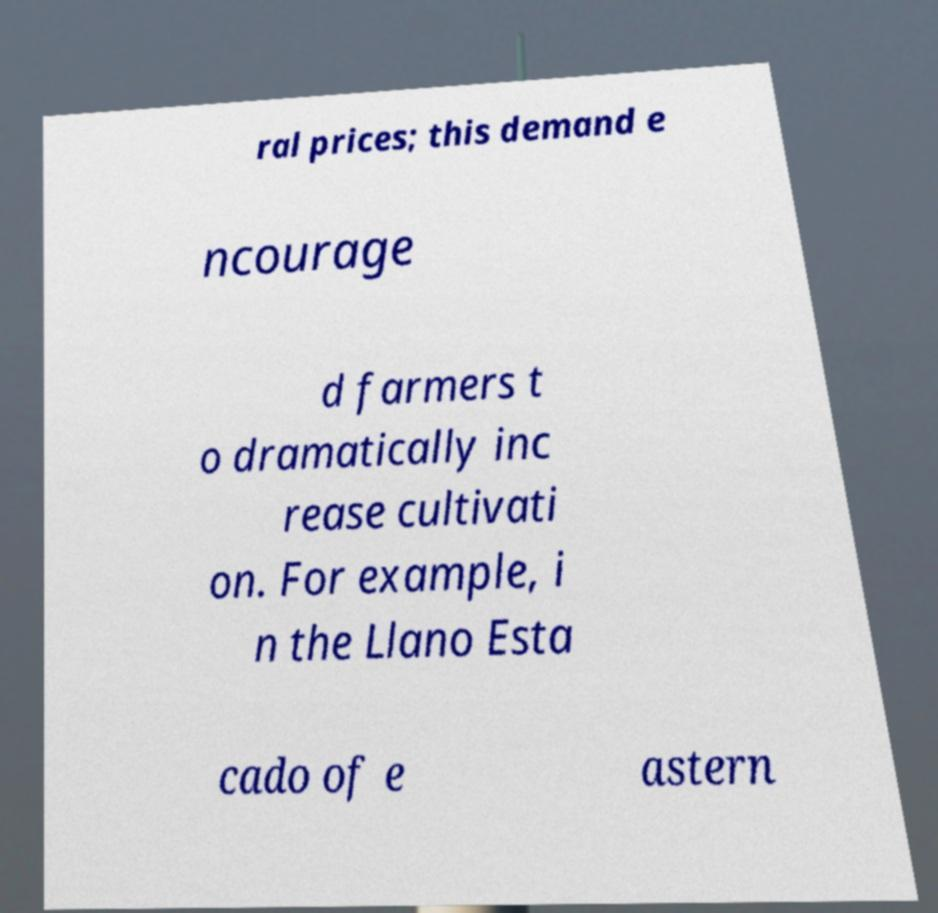For documentation purposes, I need the text within this image transcribed. Could you provide that? ral prices; this demand e ncourage d farmers t o dramatically inc rease cultivati on. For example, i n the Llano Esta cado of e astern 